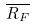Convert formula to latex. <formula><loc_0><loc_0><loc_500><loc_500>\overline { R _ { F } }</formula> 